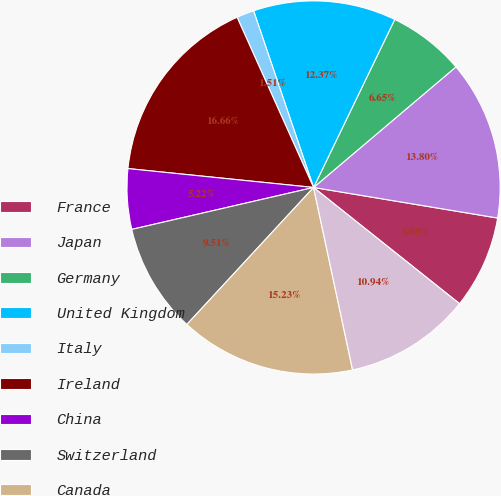Convert chart. <chart><loc_0><loc_0><loc_500><loc_500><pie_chart><fcel>France<fcel>Japan<fcel>Germany<fcel>United Kingdom<fcel>Italy<fcel>Ireland<fcel>China<fcel>Switzerland<fcel>Canada<fcel>Australia<nl><fcel>8.08%<fcel>13.8%<fcel>6.65%<fcel>12.37%<fcel>1.51%<fcel>16.66%<fcel>5.22%<fcel>9.51%<fcel>15.23%<fcel>10.94%<nl></chart> 